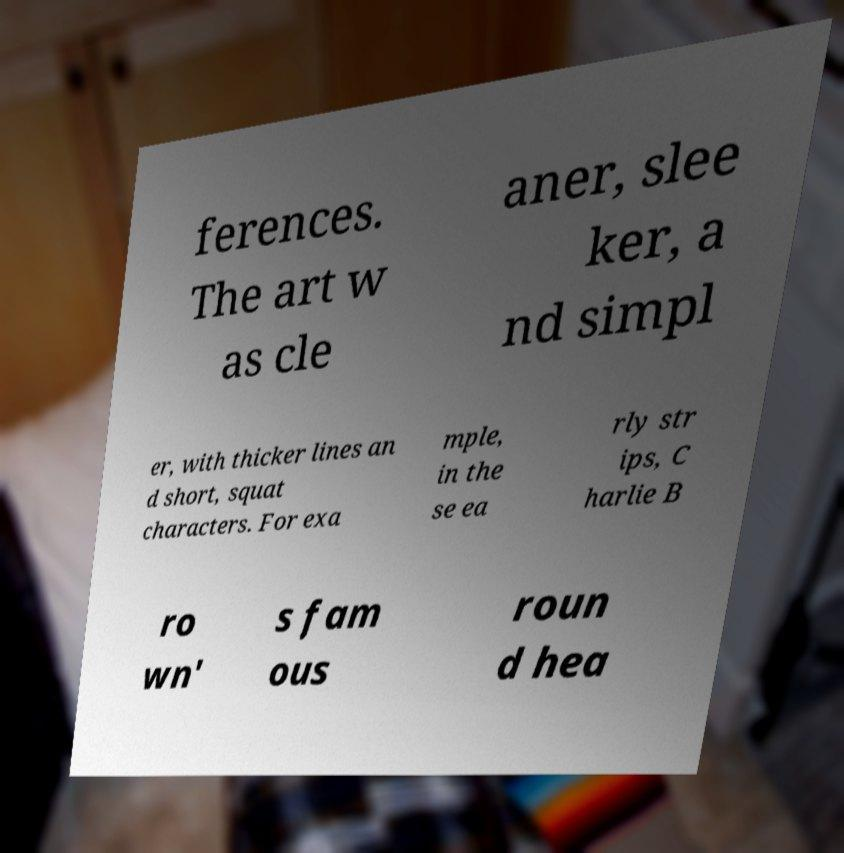What messages or text are displayed in this image? I need them in a readable, typed format. ferences. The art w as cle aner, slee ker, a nd simpl er, with thicker lines an d short, squat characters. For exa mple, in the se ea rly str ips, C harlie B ro wn' s fam ous roun d hea 